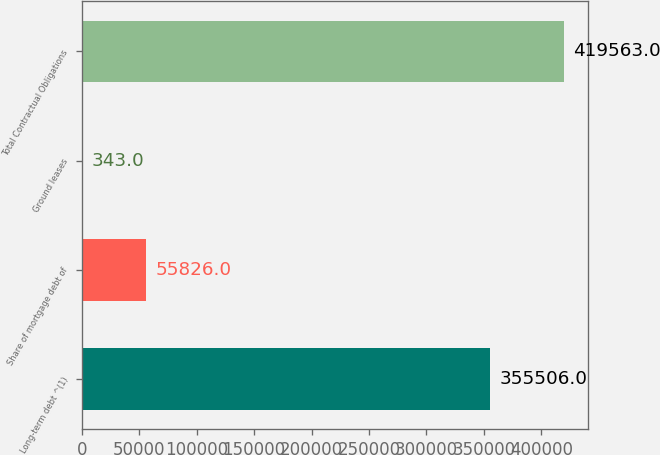Convert chart. <chart><loc_0><loc_0><loc_500><loc_500><bar_chart><fcel>Long-term debt ^(1)<fcel>Share of mortgage debt of<fcel>Ground leases<fcel>Total Contractual Obligations<nl><fcel>355506<fcel>55826<fcel>343<fcel>419563<nl></chart> 